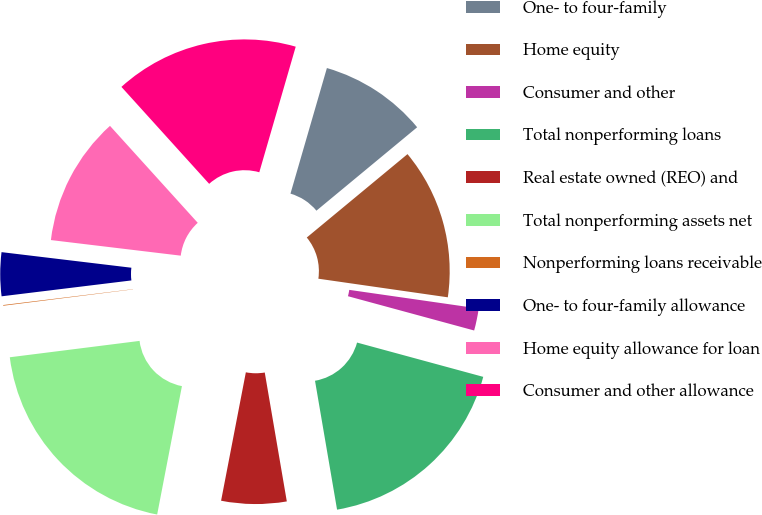Convert chart. <chart><loc_0><loc_0><loc_500><loc_500><pie_chart><fcel>One- to four-family<fcel>Home equity<fcel>Consumer and other<fcel>Total nonperforming loans<fcel>Real estate owned (REO) and<fcel>Total nonperforming assets net<fcel>Nonperforming loans receivable<fcel>One- to four-family allowance<fcel>Home equity allowance for loan<fcel>Consumer and other allowance<nl><fcel>9.5%<fcel>13.28%<fcel>1.95%<fcel>18.08%<fcel>5.73%<fcel>19.97%<fcel>0.06%<fcel>3.84%<fcel>11.39%<fcel>16.2%<nl></chart> 